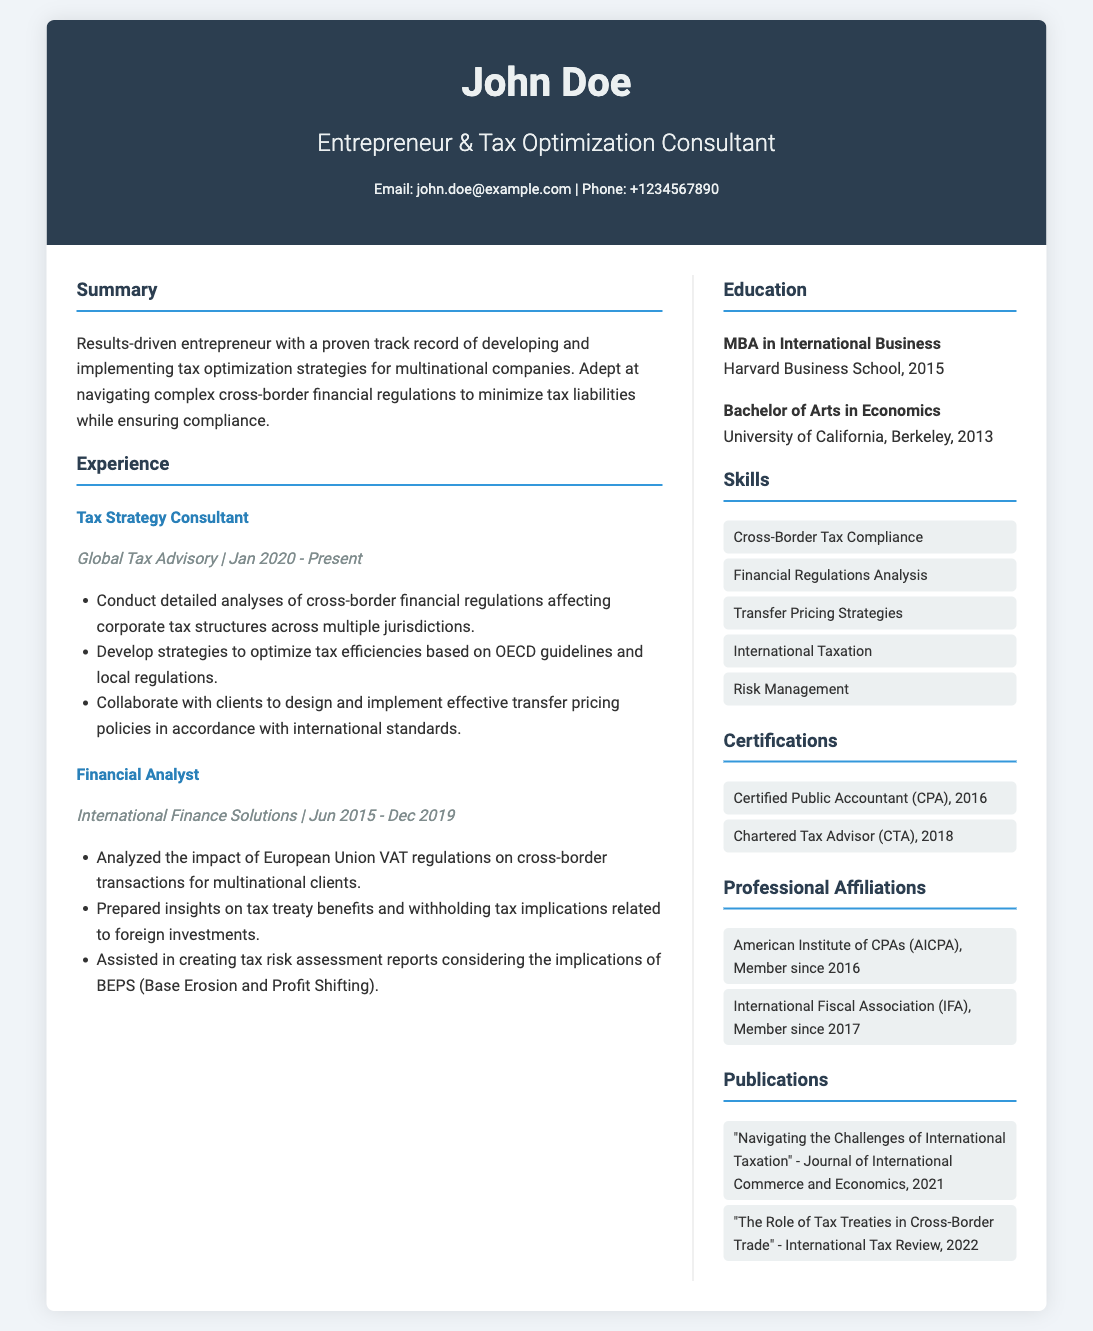What is the name of the consultant? The name of the consultant is prominently displayed at the top of the document.
Answer: John Doe What is the consultant's current position? The current position is listed under the experience section of the document.
Answer: Tax Strategy Consultant Which company is the consultant currently employed by? The company is indicated alongside the job title in the experience section.
Answer: Global Tax Advisory What degree does the consultant hold from Harvard Business School? The degree is stated in the education section with the institution name and year.
Answer: MBA in International Business What year did the consultant obtain their Bachelor's degree? The year is mentioned next to the degree in the education section.
Answer: 2013 Which certification was obtained by the consultant in 2016? The document lists the certifications along with the year obtained.
Answer: Certified Public Accountant (CPA) How many years of experience does the consultant have in tax strategy consulting? This can be derived from the duration listed in the experience section.
Answer: 3 years What is one area of expertise mentioned under skills? The skills section lists specific areas of expertise.
Answer: Cross-Border Tax Compliance What journal published an article by the consultant in 2021? The publication section provides titles along with the source.
Answer: Journal of International Commerce and Economics Which professional affiliation joined the consultant in 2017? The affiliations section provides the names of the organizations and the years of membership.
Answer: International Fiscal Association (IFA) 